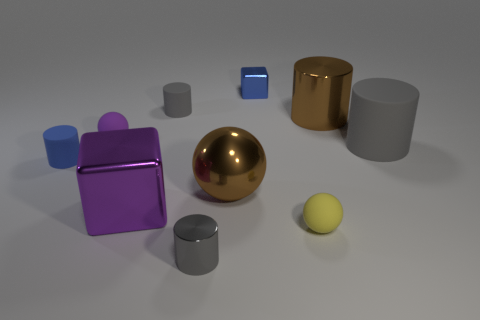Are there an equal number of large cylinders that are behind the large gray matte thing and small gray shiny objects?
Ensure brevity in your answer.  Yes. Does the yellow object have the same size as the purple cube?
Your answer should be compact. No. What is the tiny cylinder that is both behind the gray metallic cylinder and right of the blue cylinder made of?
Provide a short and direct response. Rubber. What number of gray matte objects have the same shape as the gray metal thing?
Make the answer very short. 2. There is a blue thing in front of the big brown shiny cylinder; what is its material?
Provide a succinct answer. Rubber. Are there fewer blocks that are behind the small cube than big yellow cubes?
Offer a terse response. No. Is the shape of the tiny blue metal object the same as the purple matte object?
Offer a terse response. No. Are there any other things that have the same shape as the gray metallic object?
Give a very brief answer. Yes. Is there a tiny gray shiny cylinder?
Your answer should be compact. Yes. There is a yellow thing; does it have the same shape as the brown object on the right side of the tiny blue cube?
Offer a very short reply. No. 